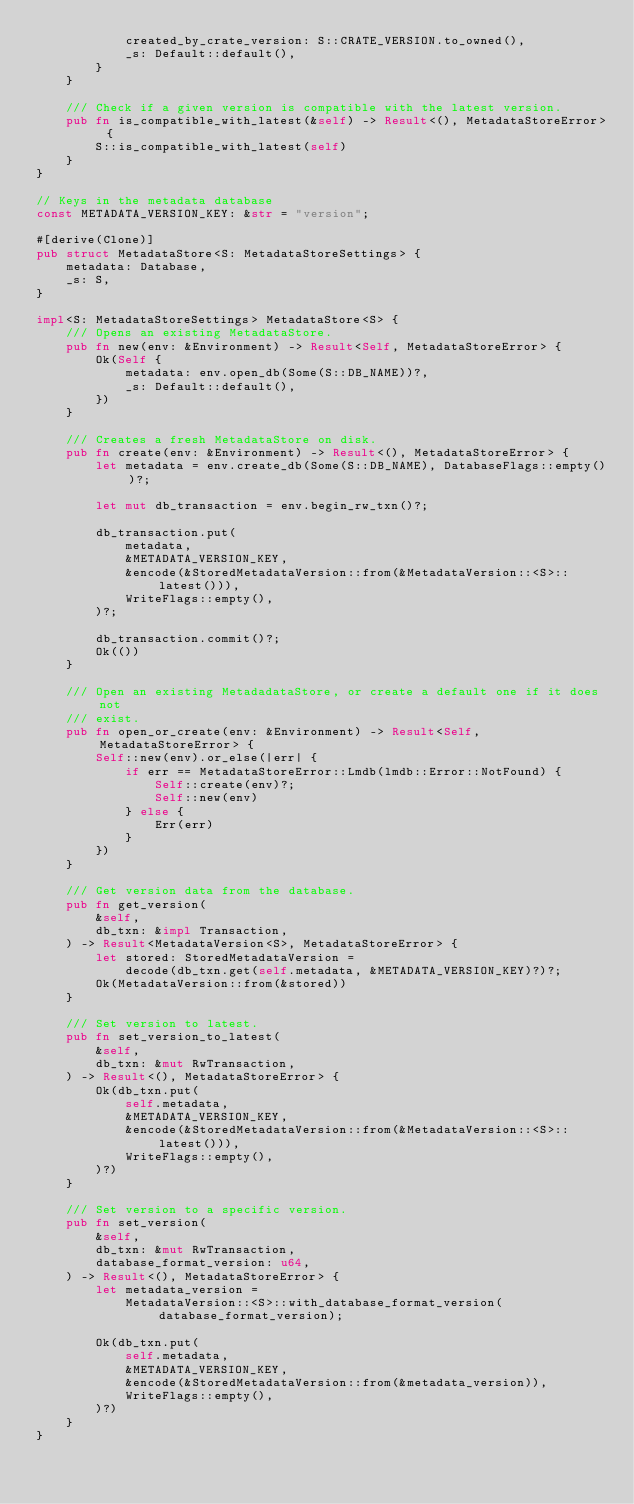<code> <loc_0><loc_0><loc_500><loc_500><_Rust_>            created_by_crate_version: S::CRATE_VERSION.to_owned(),
            _s: Default::default(),
        }
    }

    /// Check if a given version is compatible with the latest version.
    pub fn is_compatible_with_latest(&self) -> Result<(), MetadataStoreError> {
        S::is_compatible_with_latest(self)
    }
}

// Keys in the metadata database
const METADATA_VERSION_KEY: &str = "version";

#[derive(Clone)]
pub struct MetadataStore<S: MetadataStoreSettings> {
    metadata: Database,
    _s: S,
}

impl<S: MetadataStoreSettings> MetadataStore<S> {
    /// Opens an existing MetadataStore.
    pub fn new(env: &Environment) -> Result<Self, MetadataStoreError> {
        Ok(Self {
            metadata: env.open_db(Some(S::DB_NAME))?,
            _s: Default::default(),
        })
    }

    /// Creates a fresh MetadataStore on disk.
    pub fn create(env: &Environment) -> Result<(), MetadataStoreError> {
        let metadata = env.create_db(Some(S::DB_NAME), DatabaseFlags::empty())?;

        let mut db_transaction = env.begin_rw_txn()?;

        db_transaction.put(
            metadata,
            &METADATA_VERSION_KEY,
            &encode(&StoredMetadataVersion::from(&MetadataVersion::<S>::latest())),
            WriteFlags::empty(),
        )?;

        db_transaction.commit()?;
        Ok(())
    }

    /// Open an existing MetadadataStore, or create a default one if it does not
    /// exist.
    pub fn open_or_create(env: &Environment) -> Result<Self, MetadataStoreError> {
        Self::new(env).or_else(|err| {
            if err == MetadataStoreError::Lmdb(lmdb::Error::NotFound) {
                Self::create(env)?;
                Self::new(env)
            } else {
                Err(err)
            }
        })
    }

    /// Get version data from the database.
    pub fn get_version(
        &self,
        db_txn: &impl Transaction,
    ) -> Result<MetadataVersion<S>, MetadataStoreError> {
        let stored: StoredMetadataVersion =
            decode(db_txn.get(self.metadata, &METADATA_VERSION_KEY)?)?;
        Ok(MetadataVersion::from(&stored))
    }

    /// Set version to latest.
    pub fn set_version_to_latest(
        &self,
        db_txn: &mut RwTransaction,
    ) -> Result<(), MetadataStoreError> {
        Ok(db_txn.put(
            self.metadata,
            &METADATA_VERSION_KEY,
            &encode(&StoredMetadataVersion::from(&MetadataVersion::<S>::latest())),
            WriteFlags::empty(),
        )?)
    }

    /// Set version to a specific version.
    pub fn set_version(
        &self,
        db_txn: &mut RwTransaction,
        database_format_version: u64,
    ) -> Result<(), MetadataStoreError> {
        let metadata_version =
            MetadataVersion::<S>::with_database_format_version(database_format_version);

        Ok(db_txn.put(
            self.metadata,
            &METADATA_VERSION_KEY,
            &encode(&StoredMetadataVersion::from(&metadata_version)),
            WriteFlags::empty(),
        )?)
    }
}
</code> 